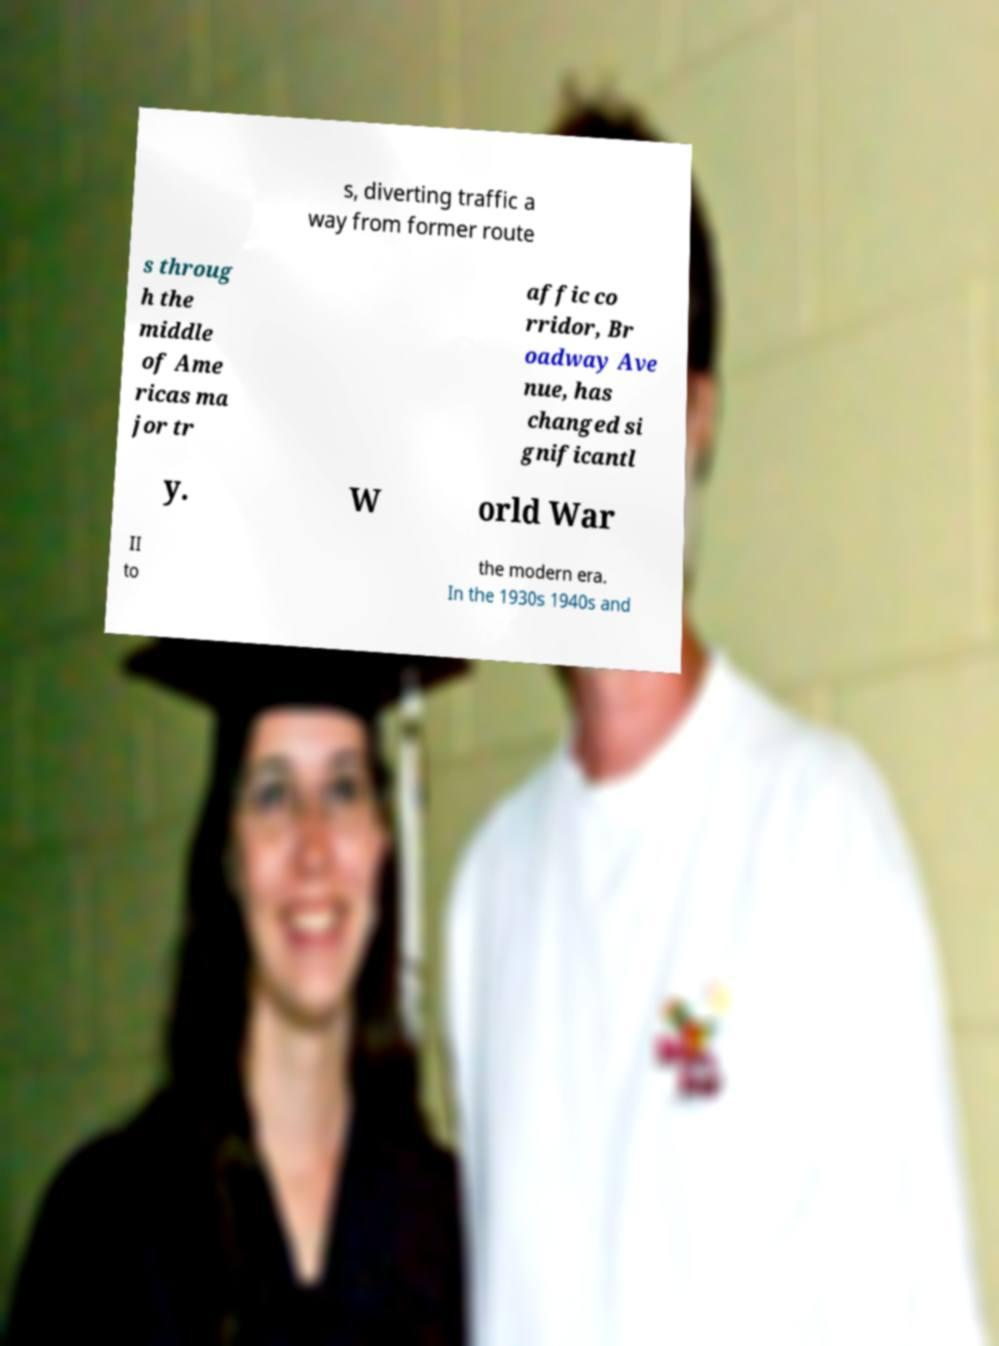Could you extract and type out the text from this image? s, diverting traffic a way from former route s throug h the middle of Ame ricas ma jor tr affic co rridor, Br oadway Ave nue, has changed si gnificantl y. W orld War II to the modern era. In the 1930s 1940s and 